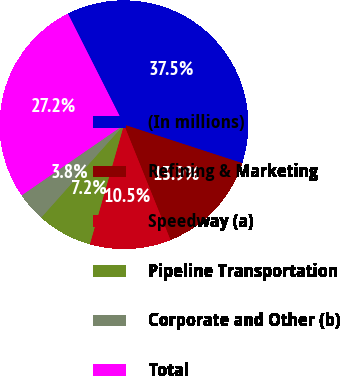Convert chart to OTSL. <chart><loc_0><loc_0><loc_500><loc_500><pie_chart><fcel>(In millions)<fcel>Refining & Marketing<fcel>Speedway (a)<fcel>Pipeline Transportation<fcel>Corporate and Other (b)<fcel>Total<nl><fcel>37.45%<fcel>13.89%<fcel>10.53%<fcel>7.16%<fcel>3.8%<fcel>27.17%<nl></chart> 